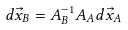<formula> <loc_0><loc_0><loc_500><loc_500>d \vec { x } _ { B } = A _ { B } ^ { - 1 } A _ { A } d \vec { x } _ { A }</formula> 